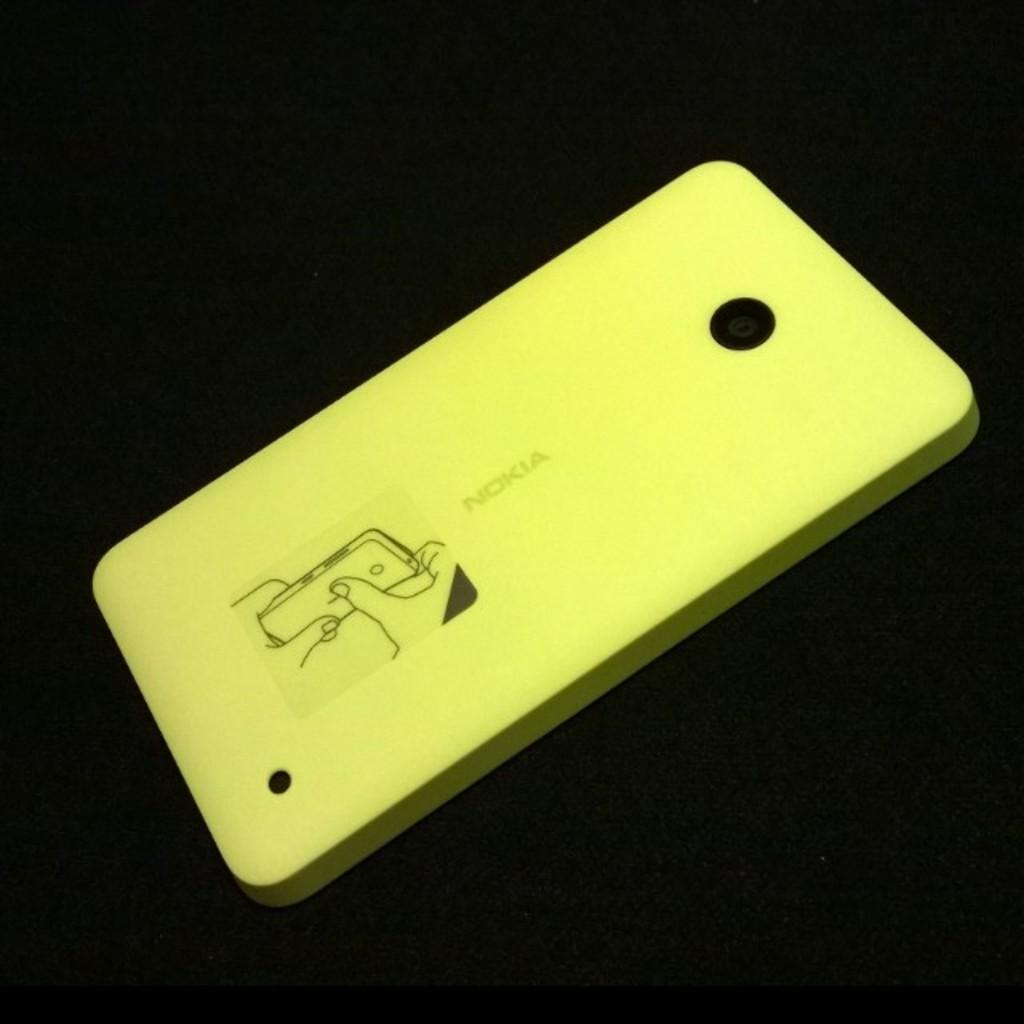<image>
Share a concise interpretation of the image provided. A yellow cover for a Nokia with instructions and pictures. 